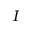Convert formula to latex. <formula><loc_0><loc_0><loc_500><loc_500>I</formula> 